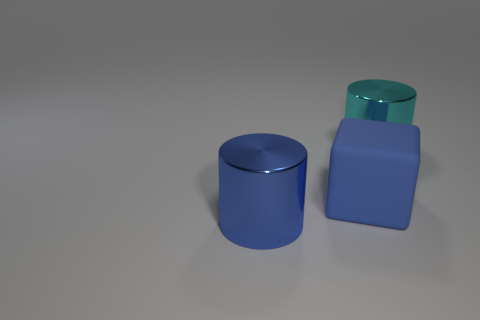What number of other objects are there of the same color as the cube?
Make the answer very short. 1. What number of tiny things are brown balls or rubber blocks?
Make the answer very short. 0. There is a metallic object that is the same color as the cube; what is its shape?
Your response must be concise. Cylinder. Does the large cylinder behind the blue shiny thing have the same material as the large cube?
Provide a succinct answer. No. The cylinder on the right side of the big thing that is on the left side of the cube is made of what material?
Ensure brevity in your answer.  Metal. How many big cyan metal things have the same shape as the large blue metallic object?
Your answer should be very brief. 1. How big is the blue object in front of the large blue object right of the metallic thing to the left of the big cyan cylinder?
Provide a short and direct response. Large. How many gray objects are large cubes or small rubber cubes?
Make the answer very short. 0. Do the large shiny thing that is to the left of the cyan shiny cylinder and the cyan metallic object have the same shape?
Your response must be concise. Yes. Is the number of matte things that are right of the blue metallic object greater than the number of large cyan matte balls?
Make the answer very short. Yes. 